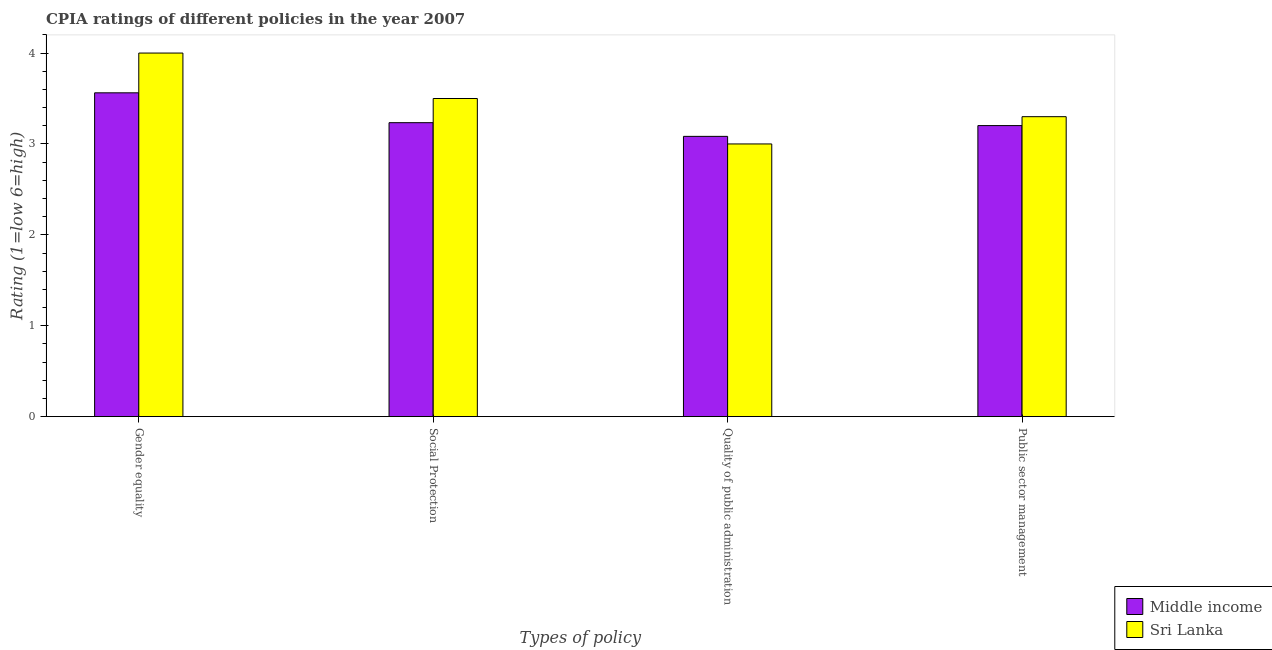Are the number of bars per tick equal to the number of legend labels?
Your answer should be very brief. Yes. How many bars are there on the 1st tick from the left?
Offer a very short reply. 2. How many bars are there on the 4th tick from the right?
Keep it short and to the point. 2. What is the label of the 2nd group of bars from the left?
Your answer should be compact. Social Protection. What is the cpia rating of social protection in Middle income?
Provide a succinct answer. 3.23. In which country was the cpia rating of public sector management maximum?
Ensure brevity in your answer.  Sri Lanka. What is the total cpia rating of public sector management in the graph?
Provide a succinct answer. 6.5. What is the difference between the cpia rating of gender equality in Sri Lanka and that in Middle income?
Your answer should be very brief. 0.44. What is the difference between the cpia rating of public sector management in Sri Lanka and the cpia rating of quality of public administration in Middle income?
Your answer should be very brief. 0.22. What is the average cpia rating of social protection per country?
Make the answer very short. 3.37. What is the difference between the cpia rating of public sector management and cpia rating of social protection in Sri Lanka?
Your answer should be very brief. -0.2. In how many countries, is the cpia rating of social protection greater than 1.2 ?
Make the answer very short. 2. What is the ratio of the cpia rating of quality of public administration in Middle income to that in Sri Lanka?
Give a very brief answer. 1.03. What is the difference between the highest and the second highest cpia rating of public sector management?
Give a very brief answer. 0.1. What is the difference between the highest and the lowest cpia rating of social protection?
Your response must be concise. 0.27. In how many countries, is the cpia rating of public sector management greater than the average cpia rating of public sector management taken over all countries?
Your response must be concise. 1. What does the 2nd bar from the right in Public sector management represents?
Make the answer very short. Middle income. Are all the bars in the graph horizontal?
Your answer should be very brief. No. What is the difference between two consecutive major ticks on the Y-axis?
Give a very brief answer. 1. Does the graph contain any zero values?
Your response must be concise. No. Where does the legend appear in the graph?
Your response must be concise. Bottom right. How many legend labels are there?
Make the answer very short. 2. How are the legend labels stacked?
Keep it short and to the point. Vertical. What is the title of the graph?
Provide a succinct answer. CPIA ratings of different policies in the year 2007. Does "Curacao" appear as one of the legend labels in the graph?
Your answer should be very brief. No. What is the label or title of the X-axis?
Make the answer very short. Types of policy. What is the Rating (1=low 6=high) of Middle income in Gender equality?
Offer a terse response. 3.56. What is the Rating (1=low 6=high) in Sri Lanka in Gender equality?
Provide a succinct answer. 4. What is the Rating (1=low 6=high) in Middle income in Social Protection?
Give a very brief answer. 3.23. What is the Rating (1=low 6=high) of Middle income in Quality of public administration?
Provide a succinct answer. 3.08. What is the Rating (1=low 6=high) of Sri Lanka in Quality of public administration?
Your answer should be compact. 3. What is the Rating (1=low 6=high) of Middle income in Public sector management?
Your answer should be compact. 3.2. Across all Types of policy, what is the maximum Rating (1=low 6=high) in Middle income?
Provide a succinct answer. 3.56. Across all Types of policy, what is the minimum Rating (1=low 6=high) in Middle income?
Your answer should be very brief. 3.08. What is the total Rating (1=low 6=high) in Middle income in the graph?
Give a very brief answer. 13.08. What is the total Rating (1=low 6=high) of Sri Lanka in the graph?
Your answer should be very brief. 13.8. What is the difference between the Rating (1=low 6=high) in Middle income in Gender equality and that in Social Protection?
Provide a short and direct response. 0.33. What is the difference between the Rating (1=low 6=high) in Middle income in Gender equality and that in Quality of public administration?
Provide a short and direct response. 0.48. What is the difference between the Rating (1=low 6=high) of Middle income in Gender equality and that in Public sector management?
Ensure brevity in your answer.  0.36. What is the difference between the Rating (1=low 6=high) of Middle income in Social Protection and that in Quality of public administration?
Ensure brevity in your answer.  0.15. What is the difference between the Rating (1=low 6=high) of Sri Lanka in Social Protection and that in Quality of public administration?
Your answer should be compact. 0.5. What is the difference between the Rating (1=low 6=high) of Middle income in Social Protection and that in Public sector management?
Your answer should be very brief. 0.03. What is the difference between the Rating (1=low 6=high) of Middle income in Quality of public administration and that in Public sector management?
Your answer should be compact. -0.12. What is the difference between the Rating (1=low 6=high) in Sri Lanka in Quality of public administration and that in Public sector management?
Make the answer very short. -0.3. What is the difference between the Rating (1=low 6=high) in Middle income in Gender equality and the Rating (1=low 6=high) in Sri Lanka in Social Protection?
Your answer should be compact. 0.06. What is the difference between the Rating (1=low 6=high) in Middle income in Gender equality and the Rating (1=low 6=high) in Sri Lanka in Quality of public administration?
Offer a terse response. 0.56. What is the difference between the Rating (1=low 6=high) in Middle income in Gender equality and the Rating (1=low 6=high) in Sri Lanka in Public sector management?
Ensure brevity in your answer.  0.26. What is the difference between the Rating (1=low 6=high) of Middle income in Social Protection and the Rating (1=low 6=high) of Sri Lanka in Quality of public administration?
Provide a short and direct response. 0.23. What is the difference between the Rating (1=low 6=high) in Middle income in Social Protection and the Rating (1=low 6=high) in Sri Lanka in Public sector management?
Your answer should be very brief. -0.07. What is the difference between the Rating (1=low 6=high) in Middle income in Quality of public administration and the Rating (1=low 6=high) in Sri Lanka in Public sector management?
Keep it short and to the point. -0.22. What is the average Rating (1=low 6=high) of Middle income per Types of policy?
Give a very brief answer. 3.27. What is the average Rating (1=low 6=high) of Sri Lanka per Types of policy?
Offer a very short reply. 3.45. What is the difference between the Rating (1=low 6=high) of Middle income and Rating (1=low 6=high) of Sri Lanka in Gender equality?
Ensure brevity in your answer.  -0.44. What is the difference between the Rating (1=low 6=high) in Middle income and Rating (1=low 6=high) in Sri Lanka in Social Protection?
Provide a succinct answer. -0.27. What is the difference between the Rating (1=low 6=high) of Middle income and Rating (1=low 6=high) of Sri Lanka in Quality of public administration?
Offer a very short reply. 0.08. What is the difference between the Rating (1=low 6=high) of Middle income and Rating (1=low 6=high) of Sri Lanka in Public sector management?
Your response must be concise. -0.1. What is the ratio of the Rating (1=low 6=high) in Middle income in Gender equality to that in Social Protection?
Keep it short and to the point. 1.1. What is the ratio of the Rating (1=low 6=high) of Middle income in Gender equality to that in Quality of public administration?
Your response must be concise. 1.16. What is the ratio of the Rating (1=low 6=high) in Sri Lanka in Gender equality to that in Quality of public administration?
Your answer should be very brief. 1.33. What is the ratio of the Rating (1=low 6=high) in Middle income in Gender equality to that in Public sector management?
Offer a terse response. 1.11. What is the ratio of the Rating (1=low 6=high) of Sri Lanka in Gender equality to that in Public sector management?
Offer a terse response. 1.21. What is the ratio of the Rating (1=low 6=high) in Middle income in Social Protection to that in Quality of public administration?
Provide a short and direct response. 1.05. What is the ratio of the Rating (1=low 6=high) in Sri Lanka in Social Protection to that in Quality of public administration?
Make the answer very short. 1.17. What is the ratio of the Rating (1=low 6=high) in Middle income in Social Protection to that in Public sector management?
Provide a succinct answer. 1.01. What is the ratio of the Rating (1=low 6=high) in Sri Lanka in Social Protection to that in Public sector management?
Keep it short and to the point. 1.06. What is the ratio of the Rating (1=low 6=high) in Middle income in Quality of public administration to that in Public sector management?
Give a very brief answer. 0.96. What is the difference between the highest and the second highest Rating (1=low 6=high) of Middle income?
Keep it short and to the point. 0.33. What is the difference between the highest and the second highest Rating (1=low 6=high) in Sri Lanka?
Provide a short and direct response. 0.5. What is the difference between the highest and the lowest Rating (1=low 6=high) in Middle income?
Ensure brevity in your answer.  0.48. What is the difference between the highest and the lowest Rating (1=low 6=high) of Sri Lanka?
Your answer should be compact. 1. 